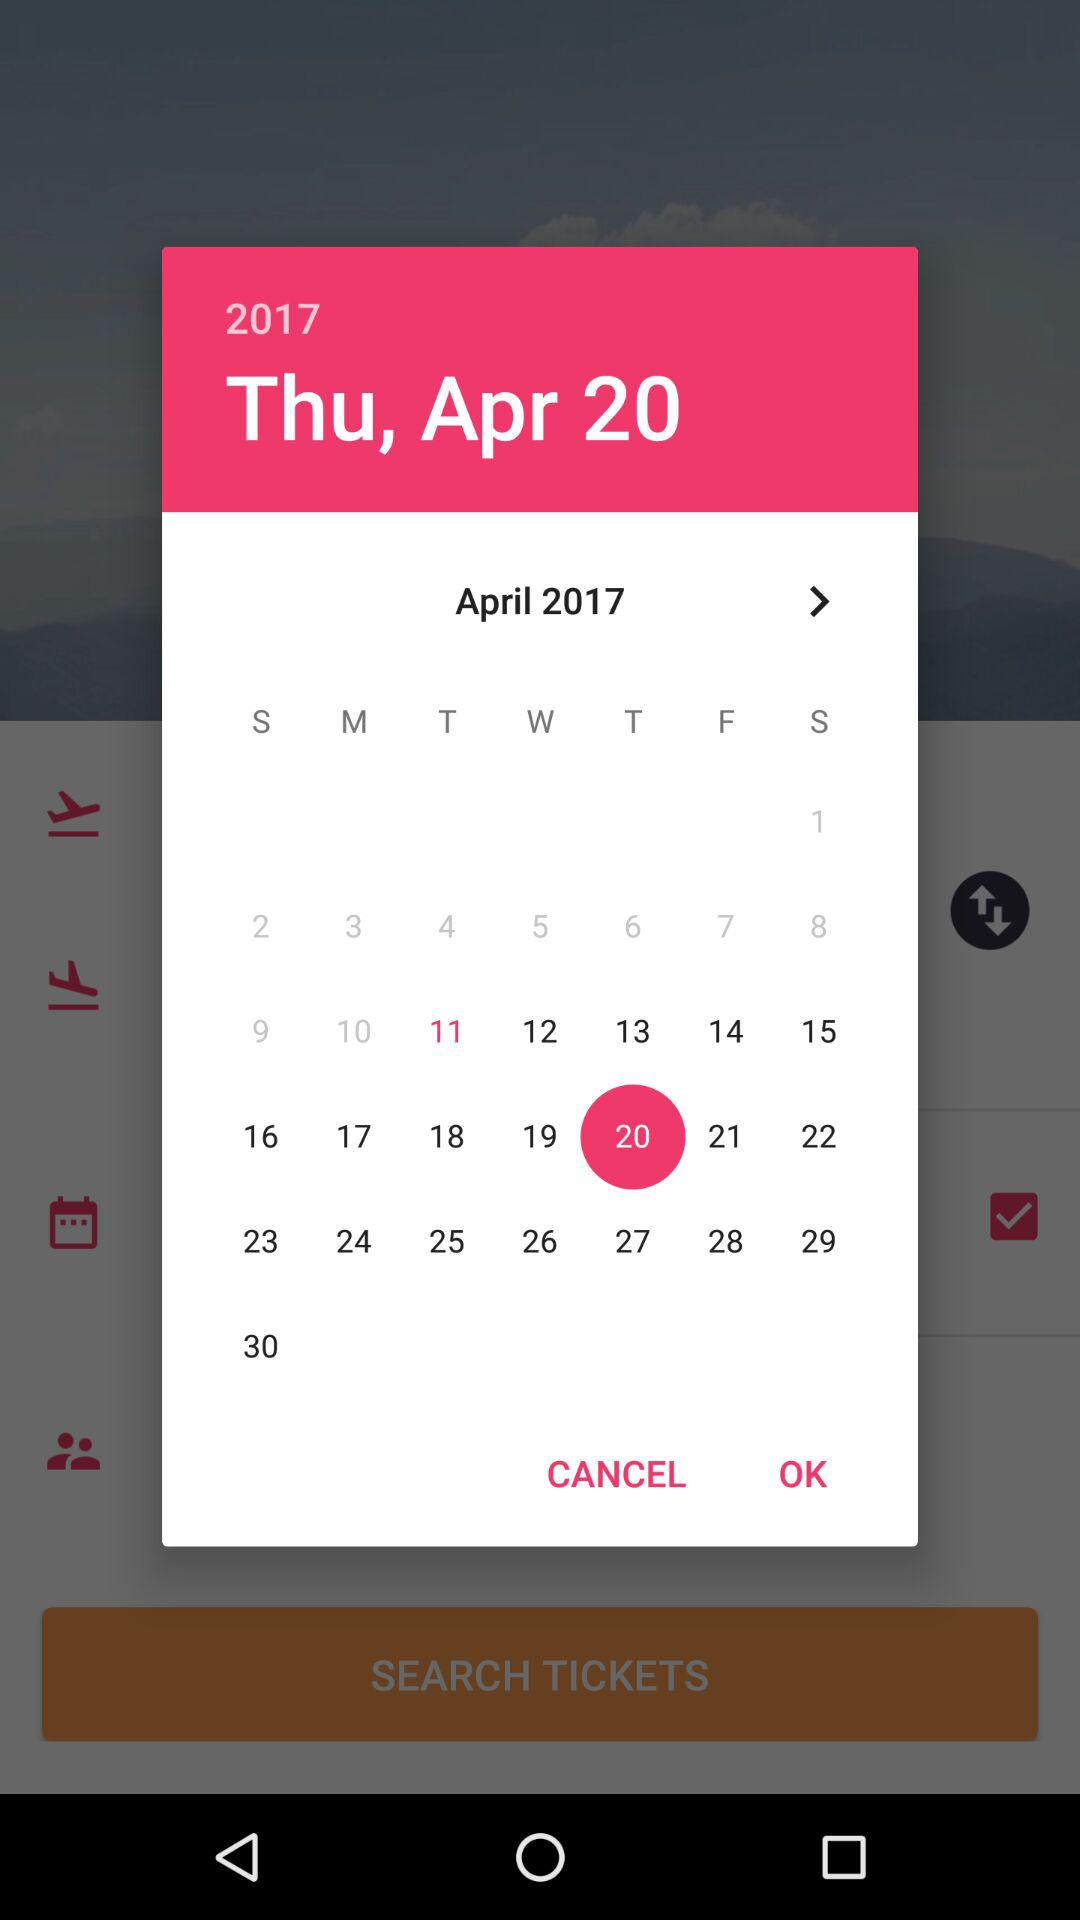What is the day on April 20? April 20 is a Thursday. 